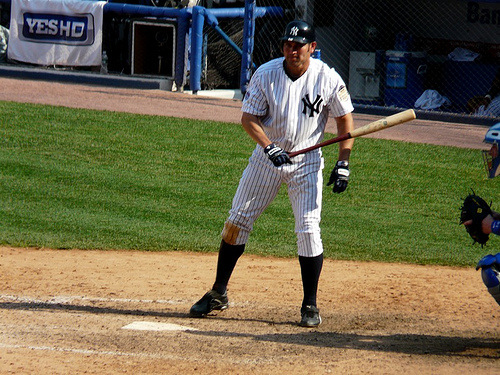Please identify all text content in this image. YESHD 